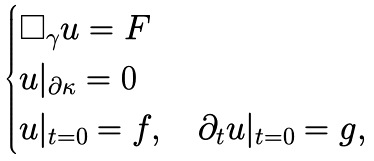Convert formula to latex. <formula><loc_0><loc_0><loc_500><loc_500>\begin{cases} \square _ { \gamma } u = F \\ u | _ { \partial \kappa } = 0 \\ u | _ { t = 0 } = f , \quad \partial _ { t } u | _ { t = 0 } = g , \end{cases}</formula> 